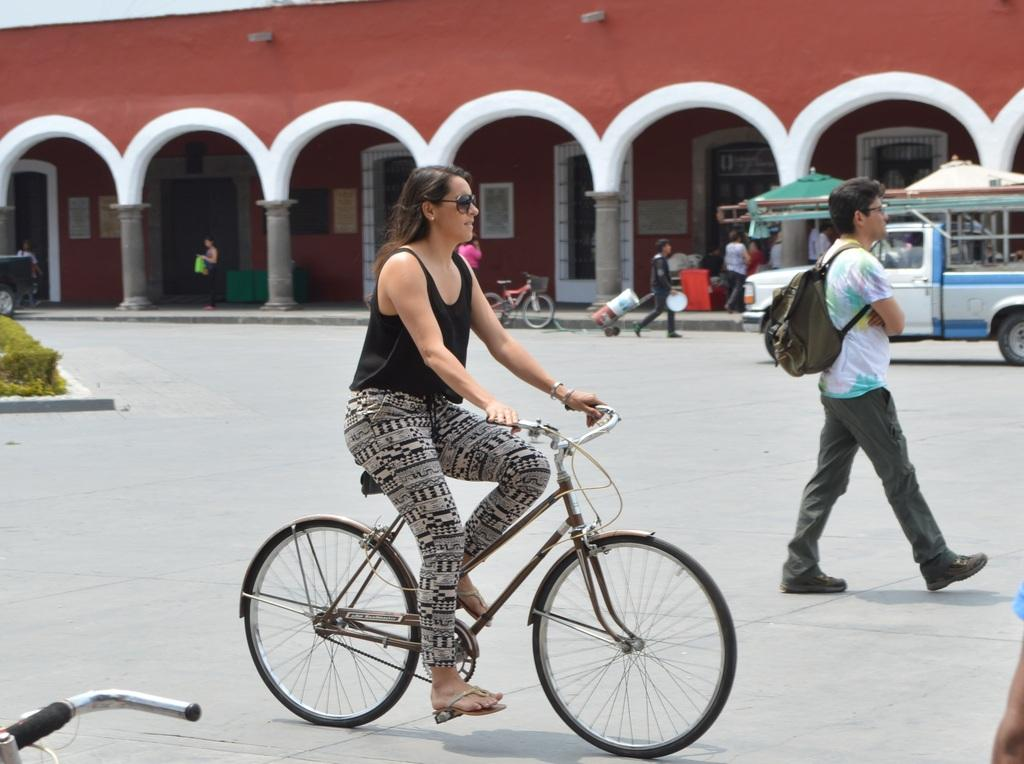Who is the main subject in the image? There is a woman in the image. What is the woman doing in the image? The woman is riding a bicycle. Where is the bicycle located? The bicycle is on the road. What can be seen in the background of the image? There is a building, doors, people, a tent, and a vehicle visible in the background. What type of drain can be seen in the image? There is no drain present in the image. Is the woman riding her bicycle in a field? The image does not show a field; it shows a woman riding a bicycle on the road. 